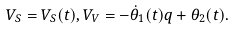<formula> <loc_0><loc_0><loc_500><loc_500>V _ { S } = V _ { S } ( t ) , V _ { V } = - \dot { \theta } _ { 1 } ( t ) q + \theta _ { 2 } ( t ) .</formula> 